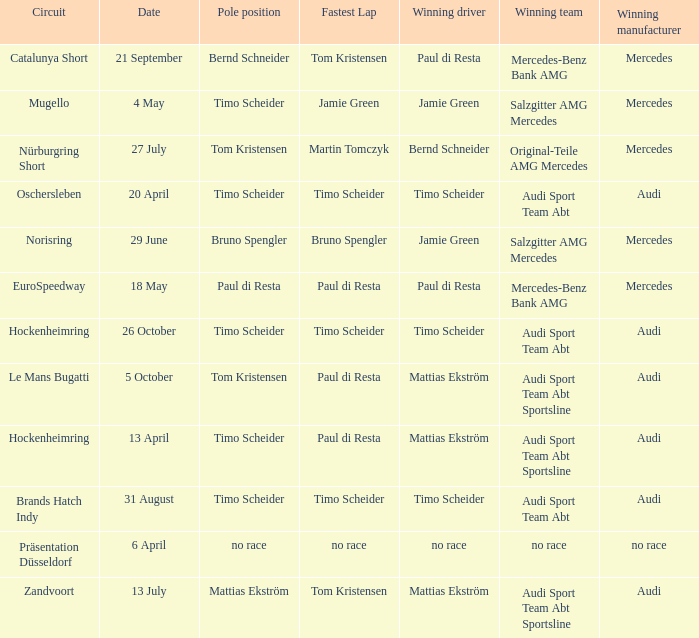Can you give me this table as a dict? {'header': ['Circuit', 'Date', 'Pole position', 'Fastest Lap', 'Winning driver', 'Winning team', 'Winning manufacturer'], 'rows': [['Catalunya Short', '21 September', 'Bernd Schneider', 'Tom Kristensen', 'Paul di Resta', 'Mercedes-Benz Bank AMG', 'Mercedes'], ['Mugello', '4 May', 'Timo Scheider', 'Jamie Green', 'Jamie Green', 'Salzgitter AMG Mercedes', 'Mercedes'], ['Nürburgring Short', '27 July', 'Tom Kristensen', 'Martin Tomczyk', 'Bernd Schneider', 'Original-Teile AMG Mercedes', 'Mercedes'], ['Oschersleben', '20 April', 'Timo Scheider', 'Timo Scheider', 'Timo Scheider', 'Audi Sport Team Abt', 'Audi'], ['Norisring', '29 June', 'Bruno Spengler', 'Bruno Spengler', 'Jamie Green', 'Salzgitter AMG Mercedes', 'Mercedes'], ['EuroSpeedway', '18 May', 'Paul di Resta', 'Paul di Resta', 'Paul di Resta', 'Mercedes-Benz Bank AMG', 'Mercedes'], ['Hockenheimring', '26 October', 'Timo Scheider', 'Timo Scheider', 'Timo Scheider', 'Audi Sport Team Abt', 'Audi'], ['Le Mans Bugatti', '5 October', 'Tom Kristensen', 'Paul di Resta', 'Mattias Ekström', 'Audi Sport Team Abt Sportsline', 'Audi'], ['Hockenheimring', '13 April', 'Timo Scheider', 'Paul di Resta', 'Mattias Ekström', 'Audi Sport Team Abt Sportsline', 'Audi'], ['Brands Hatch Indy', '31 August', 'Timo Scheider', 'Timo Scheider', 'Timo Scheider', 'Audi Sport Team Abt', 'Audi'], ['Präsentation Düsseldorf', '6 April', 'no race', 'no race', 'no race', 'no race', 'no race'], ['Zandvoort', '13 July', 'Mattias Ekström', 'Tom Kristensen', 'Mattias Ekström', 'Audi Sport Team Abt Sportsline', 'Audi']]} Who is the winning driver of the race with no race as the winning manufacturer? No race. 